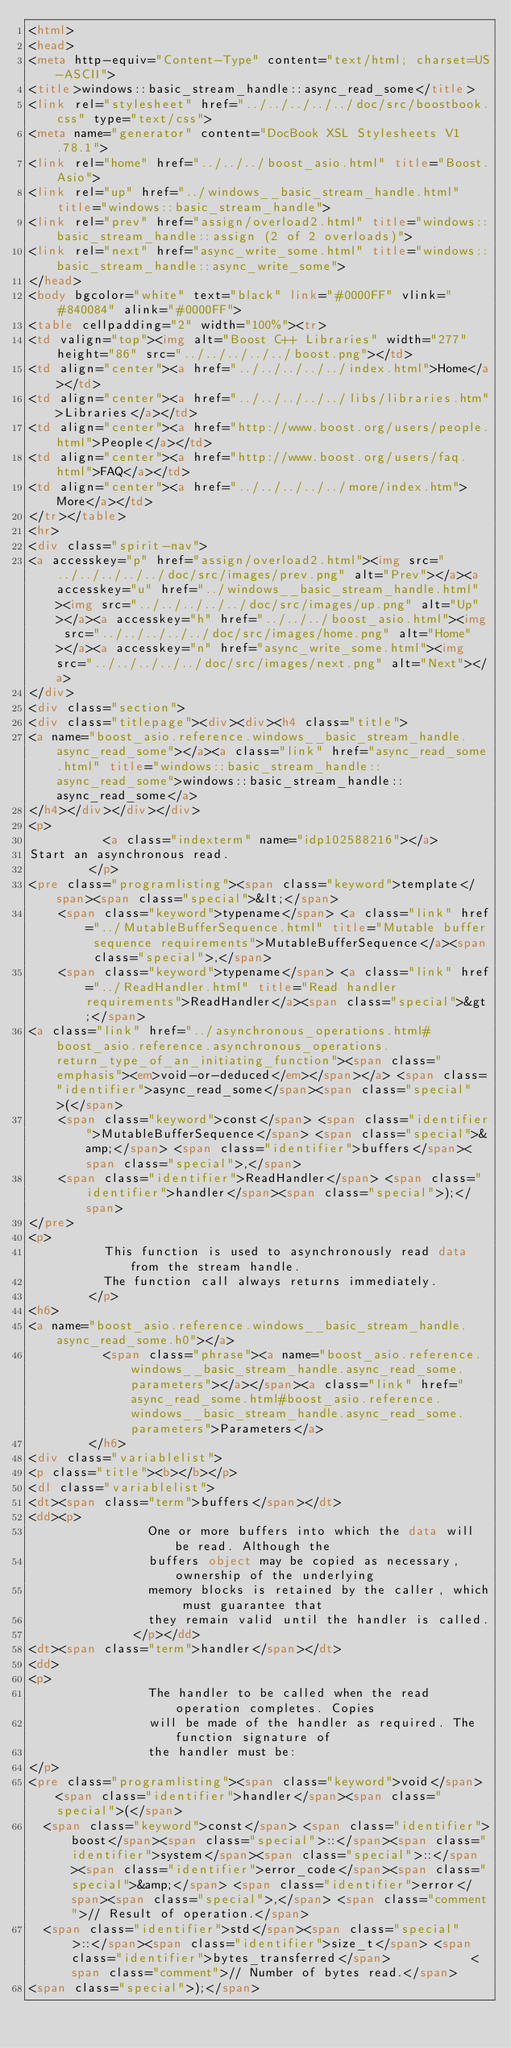Convert code to text. <code><loc_0><loc_0><loc_500><loc_500><_HTML_><html>
<head>
<meta http-equiv="Content-Type" content="text/html; charset=US-ASCII">
<title>windows::basic_stream_handle::async_read_some</title>
<link rel="stylesheet" href="../../../../../doc/src/boostbook.css" type="text/css">
<meta name="generator" content="DocBook XSL Stylesheets V1.78.1">
<link rel="home" href="../../../boost_asio.html" title="Boost.Asio">
<link rel="up" href="../windows__basic_stream_handle.html" title="windows::basic_stream_handle">
<link rel="prev" href="assign/overload2.html" title="windows::basic_stream_handle::assign (2 of 2 overloads)">
<link rel="next" href="async_write_some.html" title="windows::basic_stream_handle::async_write_some">
</head>
<body bgcolor="white" text="black" link="#0000FF" vlink="#840084" alink="#0000FF">
<table cellpadding="2" width="100%"><tr>
<td valign="top"><img alt="Boost C++ Libraries" width="277" height="86" src="../../../../../boost.png"></td>
<td align="center"><a href="../../../../../index.html">Home</a></td>
<td align="center"><a href="../../../../../libs/libraries.htm">Libraries</a></td>
<td align="center"><a href="http://www.boost.org/users/people.html">People</a></td>
<td align="center"><a href="http://www.boost.org/users/faq.html">FAQ</a></td>
<td align="center"><a href="../../../../../more/index.htm">More</a></td>
</tr></table>
<hr>
<div class="spirit-nav">
<a accesskey="p" href="assign/overload2.html"><img src="../../../../../doc/src/images/prev.png" alt="Prev"></a><a accesskey="u" href="../windows__basic_stream_handle.html"><img src="../../../../../doc/src/images/up.png" alt="Up"></a><a accesskey="h" href="../../../boost_asio.html"><img src="../../../../../doc/src/images/home.png" alt="Home"></a><a accesskey="n" href="async_write_some.html"><img src="../../../../../doc/src/images/next.png" alt="Next"></a>
</div>
<div class="section">
<div class="titlepage"><div><div><h4 class="title">
<a name="boost_asio.reference.windows__basic_stream_handle.async_read_some"></a><a class="link" href="async_read_some.html" title="windows::basic_stream_handle::async_read_some">windows::basic_stream_handle::async_read_some</a>
</h4></div></div></div>
<p>
          <a class="indexterm" name="idp102588216"></a> 
Start an asynchronous read.
        </p>
<pre class="programlisting"><span class="keyword">template</span><span class="special">&lt;</span>
    <span class="keyword">typename</span> <a class="link" href="../MutableBufferSequence.html" title="Mutable buffer sequence requirements">MutableBufferSequence</a><span class="special">,</span>
    <span class="keyword">typename</span> <a class="link" href="../ReadHandler.html" title="Read handler requirements">ReadHandler</a><span class="special">&gt;</span>
<a class="link" href="../asynchronous_operations.html#boost_asio.reference.asynchronous_operations.return_type_of_an_initiating_function"><span class="emphasis"><em>void-or-deduced</em></span></a> <span class="identifier">async_read_some</span><span class="special">(</span>
    <span class="keyword">const</span> <span class="identifier">MutableBufferSequence</span> <span class="special">&amp;</span> <span class="identifier">buffers</span><span class="special">,</span>
    <span class="identifier">ReadHandler</span> <span class="identifier">handler</span><span class="special">);</span>
</pre>
<p>
          This function is used to asynchronously read data from the stream handle.
          The function call always returns immediately.
        </p>
<h6>
<a name="boost_asio.reference.windows__basic_stream_handle.async_read_some.h0"></a>
          <span class="phrase"><a name="boost_asio.reference.windows__basic_stream_handle.async_read_some.parameters"></a></span><a class="link" href="async_read_some.html#boost_asio.reference.windows__basic_stream_handle.async_read_some.parameters">Parameters</a>
        </h6>
<div class="variablelist">
<p class="title"><b></b></p>
<dl class="variablelist">
<dt><span class="term">buffers</span></dt>
<dd><p>
                One or more buffers into which the data will be read. Although the
                buffers object may be copied as necessary, ownership of the underlying
                memory blocks is retained by the caller, which must guarantee that
                they remain valid until the handler is called.
              </p></dd>
<dt><span class="term">handler</span></dt>
<dd>
<p>
                The handler to be called when the read operation completes. Copies
                will be made of the handler as required. The function signature of
                the handler must be:
</p>
<pre class="programlisting"><span class="keyword">void</span> <span class="identifier">handler</span><span class="special">(</span>
  <span class="keyword">const</span> <span class="identifier">boost</span><span class="special">::</span><span class="identifier">system</span><span class="special">::</span><span class="identifier">error_code</span><span class="special">&amp;</span> <span class="identifier">error</span><span class="special">,</span> <span class="comment">// Result of operation.</span>
  <span class="identifier">std</span><span class="special">::</span><span class="identifier">size_t</span> <span class="identifier">bytes_transferred</span>           <span class="comment">// Number of bytes read.</span>
<span class="special">);</span></code> 